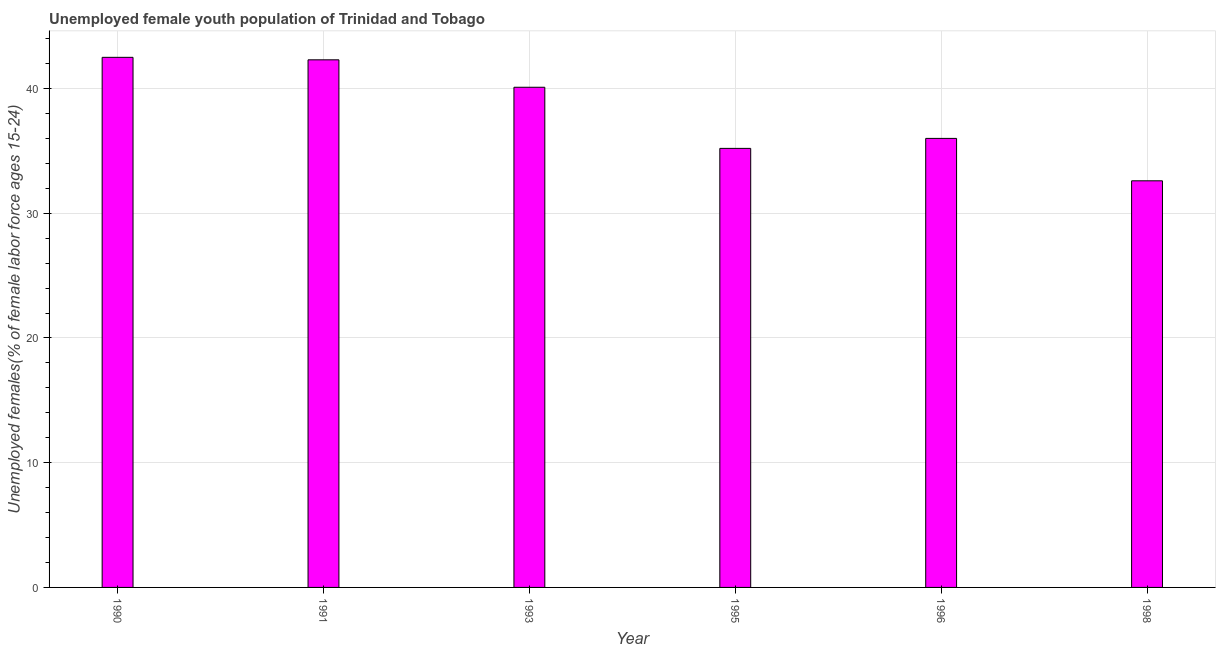Does the graph contain grids?
Your answer should be very brief. Yes. What is the title of the graph?
Give a very brief answer. Unemployed female youth population of Trinidad and Tobago. What is the label or title of the Y-axis?
Keep it short and to the point. Unemployed females(% of female labor force ages 15-24). What is the unemployed female youth in 1998?
Give a very brief answer. 32.6. Across all years, what is the maximum unemployed female youth?
Your answer should be compact. 42.5. Across all years, what is the minimum unemployed female youth?
Make the answer very short. 32.6. In which year was the unemployed female youth minimum?
Keep it short and to the point. 1998. What is the sum of the unemployed female youth?
Make the answer very short. 228.7. What is the difference between the unemployed female youth in 1990 and 1991?
Keep it short and to the point. 0.2. What is the average unemployed female youth per year?
Make the answer very short. 38.12. What is the median unemployed female youth?
Offer a very short reply. 38.05. In how many years, is the unemployed female youth greater than 6 %?
Ensure brevity in your answer.  6. Do a majority of the years between 1993 and 1996 (inclusive) have unemployed female youth greater than 38 %?
Provide a short and direct response. No. What is the ratio of the unemployed female youth in 1990 to that in 1993?
Provide a short and direct response. 1.06. Is the unemployed female youth in 1996 less than that in 1998?
Ensure brevity in your answer.  No. Is the difference between the unemployed female youth in 1993 and 1998 greater than the difference between any two years?
Keep it short and to the point. No. What is the difference between the highest and the lowest unemployed female youth?
Make the answer very short. 9.9. In how many years, is the unemployed female youth greater than the average unemployed female youth taken over all years?
Provide a succinct answer. 3. How many bars are there?
Ensure brevity in your answer.  6. Are all the bars in the graph horizontal?
Ensure brevity in your answer.  No. How many years are there in the graph?
Make the answer very short. 6. What is the difference between two consecutive major ticks on the Y-axis?
Make the answer very short. 10. What is the Unemployed females(% of female labor force ages 15-24) of 1990?
Your response must be concise. 42.5. What is the Unemployed females(% of female labor force ages 15-24) of 1991?
Offer a terse response. 42.3. What is the Unemployed females(% of female labor force ages 15-24) of 1993?
Provide a short and direct response. 40.1. What is the Unemployed females(% of female labor force ages 15-24) in 1995?
Provide a succinct answer. 35.2. What is the Unemployed females(% of female labor force ages 15-24) of 1998?
Your answer should be very brief. 32.6. What is the difference between the Unemployed females(% of female labor force ages 15-24) in 1990 and 1991?
Provide a succinct answer. 0.2. What is the difference between the Unemployed females(% of female labor force ages 15-24) in 1990 and 1993?
Your answer should be compact. 2.4. What is the difference between the Unemployed females(% of female labor force ages 15-24) in 1990 and 1996?
Offer a very short reply. 6.5. What is the difference between the Unemployed females(% of female labor force ages 15-24) in 1990 and 1998?
Keep it short and to the point. 9.9. What is the difference between the Unemployed females(% of female labor force ages 15-24) in 1991 and 1995?
Ensure brevity in your answer.  7.1. What is the difference between the Unemployed females(% of female labor force ages 15-24) in 1995 and 1998?
Your response must be concise. 2.6. What is the ratio of the Unemployed females(% of female labor force ages 15-24) in 1990 to that in 1991?
Make the answer very short. 1. What is the ratio of the Unemployed females(% of female labor force ages 15-24) in 1990 to that in 1993?
Keep it short and to the point. 1.06. What is the ratio of the Unemployed females(% of female labor force ages 15-24) in 1990 to that in 1995?
Make the answer very short. 1.21. What is the ratio of the Unemployed females(% of female labor force ages 15-24) in 1990 to that in 1996?
Offer a terse response. 1.18. What is the ratio of the Unemployed females(% of female labor force ages 15-24) in 1990 to that in 1998?
Give a very brief answer. 1.3. What is the ratio of the Unemployed females(% of female labor force ages 15-24) in 1991 to that in 1993?
Give a very brief answer. 1.05. What is the ratio of the Unemployed females(% of female labor force ages 15-24) in 1991 to that in 1995?
Make the answer very short. 1.2. What is the ratio of the Unemployed females(% of female labor force ages 15-24) in 1991 to that in 1996?
Provide a short and direct response. 1.18. What is the ratio of the Unemployed females(% of female labor force ages 15-24) in 1991 to that in 1998?
Make the answer very short. 1.3. What is the ratio of the Unemployed females(% of female labor force ages 15-24) in 1993 to that in 1995?
Your response must be concise. 1.14. What is the ratio of the Unemployed females(% of female labor force ages 15-24) in 1993 to that in 1996?
Ensure brevity in your answer.  1.11. What is the ratio of the Unemployed females(% of female labor force ages 15-24) in 1993 to that in 1998?
Provide a short and direct response. 1.23. What is the ratio of the Unemployed females(% of female labor force ages 15-24) in 1995 to that in 1996?
Make the answer very short. 0.98. What is the ratio of the Unemployed females(% of female labor force ages 15-24) in 1996 to that in 1998?
Your answer should be compact. 1.1. 